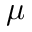Convert formula to latex. <formula><loc_0><loc_0><loc_500><loc_500>\mu</formula> 